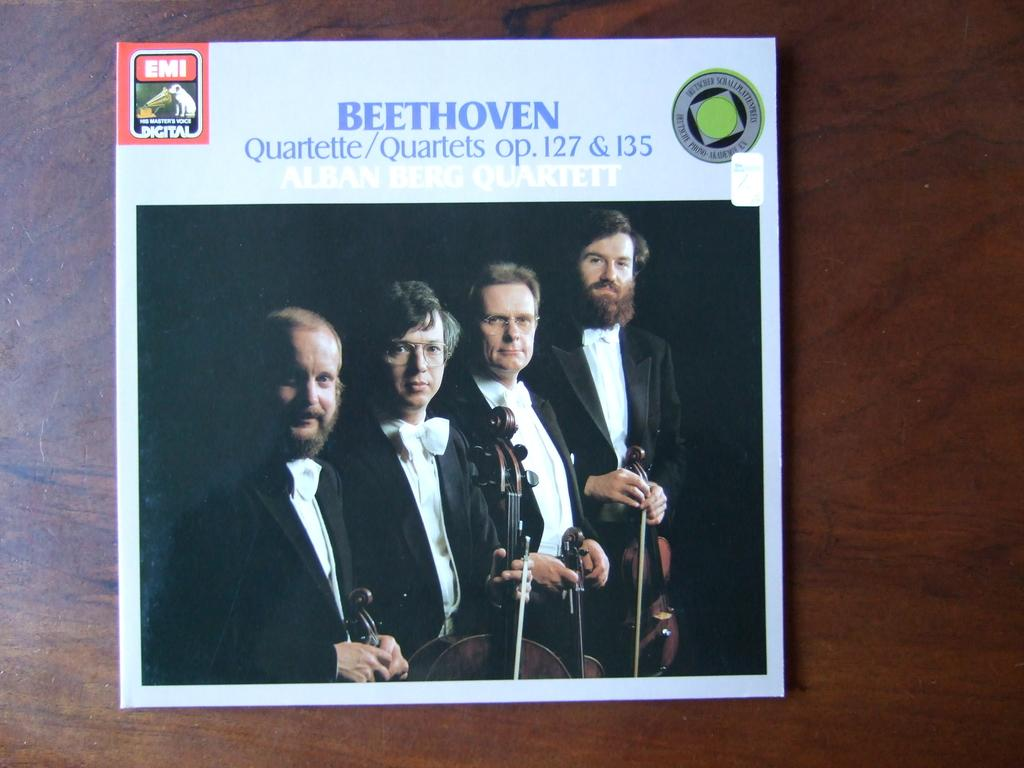What is the main object in the image? There is a flier in the image. What is the flier placed on? The flier is on a wooden surface. What can be seen in the images on the flier? The images on the flier depict persons. What are the persons wearing in the images? The persons are wearing clothes. What are the persons holding in the images? The persons are holding musical instruments. What else is present on the flier besides the images? The flier contains text. How many cans of low-fat turkey are visible in the image? There are no cans of low-fat turkey present in the image; it features a flier with images of persons holding musical instruments. 